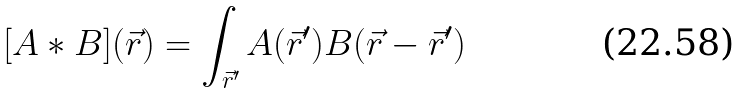Convert formula to latex. <formula><loc_0><loc_0><loc_500><loc_500>[ A * B ] ( \vec { r } ) = \int _ { \vec { r } ^ { \prime } } A ( \vec { r } ^ { \prime } ) B ( \vec { r } - \vec { r } ^ { \prime } )</formula> 